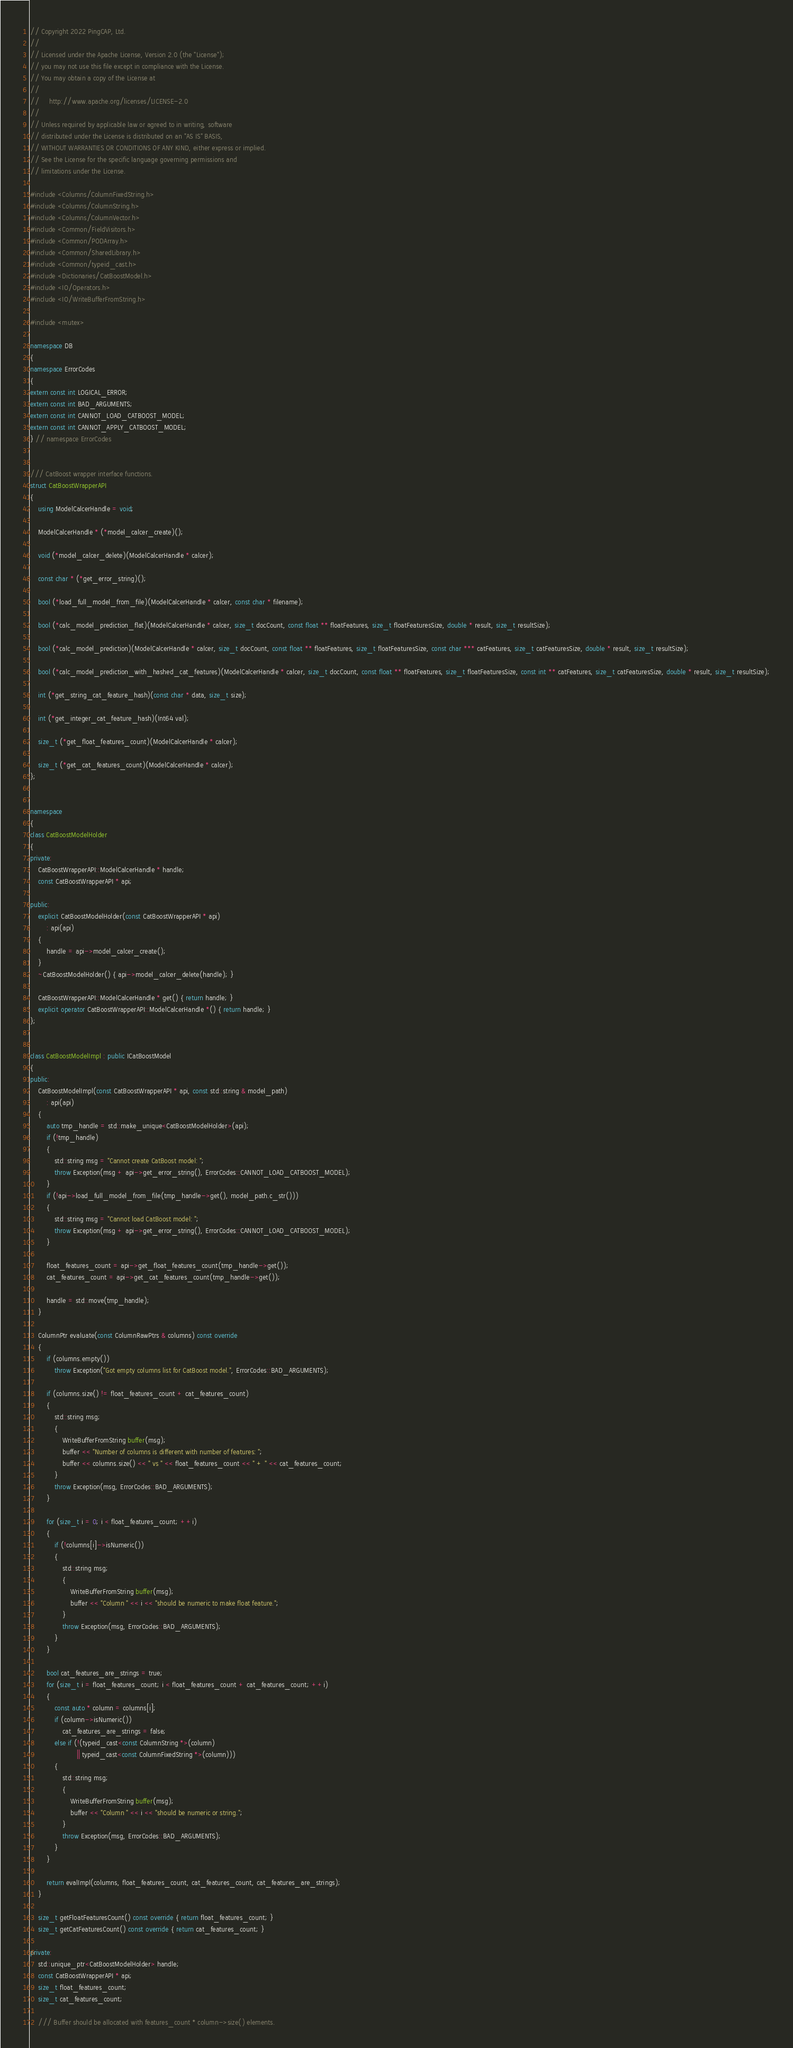<code> <loc_0><loc_0><loc_500><loc_500><_C++_>// Copyright 2022 PingCAP, Ltd.
//
// Licensed under the Apache License, Version 2.0 (the "License");
// you may not use this file except in compliance with the License.
// You may obtain a copy of the License at
//
//     http://www.apache.org/licenses/LICENSE-2.0
//
// Unless required by applicable law or agreed to in writing, software
// distributed under the License is distributed on an "AS IS" BASIS,
// WITHOUT WARRANTIES OR CONDITIONS OF ANY KIND, either express or implied.
// See the License for the specific language governing permissions and
// limitations under the License.

#include <Columns/ColumnFixedString.h>
#include <Columns/ColumnString.h>
#include <Columns/ColumnVector.h>
#include <Common/FieldVisitors.h>
#include <Common/PODArray.h>
#include <Common/SharedLibrary.h>
#include <Common/typeid_cast.h>
#include <Dictionaries/CatBoostModel.h>
#include <IO/Operators.h>
#include <IO/WriteBufferFromString.h>

#include <mutex>

namespace DB
{
namespace ErrorCodes
{
extern const int LOGICAL_ERROR;
extern const int BAD_ARGUMENTS;
extern const int CANNOT_LOAD_CATBOOST_MODEL;
extern const int CANNOT_APPLY_CATBOOST_MODEL;
} // namespace ErrorCodes


/// CatBoost wrapper interface functions.
struct CatBoostWrapperAPI
{
    using ModelCalcerHandle = void;

    ModelCalcerHandle * (*model_calcer_create)();

    void (*model_calcer_delete)(ModelCalcerHandle * calcer);

    const char * (*get_error_string)();

    bool (*load_full_model_from_file)(ModelCalcerHandle * calcer, const char * filename);

    bool (*calc_model_prediction_flat)(ModelCalcerHandle * calcer, size_t docCount, const float ** floatFeatures, size_t floatFeaturesSize, double * result, size_t resultSize);

    bool (*calc_model_prediction)(ModelCalcerHandle * calcer, size_t docCount, const float ** floatFeatures, size_t floatFeaturesSize, const char *** catFeatures, size_t catFeaturesSize, double * result, size_t resultSize);

    bool (*calc_model_prediction_with_hashed_cat_features)(ModelCalcerHandle * calcer, size_t docCount, const float ** floatFeatures, size_t floatFeaturesSize, const int ** catFeatures, size_t catFeaturesSize, double * result, size_t resultSize);

    int (*get_string_cat_feature_hash)(const char * data, size_t size);

    int (*get_integer_cat_feature_hash)(Int64 val);

    size_t (*get_float_features_count)(ModelCalcerHandle * calcer);

    size_t (*get_cat_features_count)(ModelCalcerHandle * calcer);
};


namespace
{
class CatBoostModelHolder
{
private:
    CatBoostWrapperAPI::ModelCalcerHandle * handle;
    const CatBoostWrapperAPI * api;

public:
    explicit CatBoostModelHolder(const CatBoostWrapperAPI * api)
        : api(api)
    {
        handle = api->model_calcer_create();
    }
    ~CatBoostModelHolder() { api->model_calcer_delete(handle); }

    CatBoostWrapperAPI::ModelCalcerHandle * get() { return handle; }
    explicit operator CatBoostWrapperAPI::ModelCalcerHandle *() { return handle; }
};


class CatBoostModelImpl : public ICatBoostModel
{
public:
    CatBoostModelImpl(const CatBoostWrapperAPI * api, const std::string & model_path)
        : api(api)
    {
        auto tmp_handle = std::make_unique<CatBoostModelHolder>(api);
        if (!tmp_handle)
        {
            std::string msg = "Cannot create CatBoost model: ";
            throw Exception(msg + api->get_error_string(), ErrorCodes::CANNOT_LOAD_CATBOOST_MODEL);
        }
        if (!api->load_full_model_from_file(tmp_handle->get(), model_path.c_str()))
        {
            std::string msg = "Cannot load CatBoost model: ";
            throw Exception(msg + api->get_error_string(), ErrorCodes::CANNOT_LOAD_CATBOOST_MODEL);
        }

        float_features_count = api->get_float_features_count(tmp_handle->get());
        cat_features_count = api->get_cat_features_count(tmp_handle->get());

        handle = std::move(tmp_handle);
    }

    ColumnPtr evaluate(const ColumnRawPtrs & columns) const override
    {
        if (columns.empty())
            throw Exception("Got empty columns list for CatBoost model.", ErrorCodes::BAD_ARGUMENTS);

        if (columns.size() != float_features_count + cat_features_count)
        {
            std::string msg;
            {
                WriteBufferFromString buffer(msg);
                buffer << "Number of columns is different with number of features: ";
                buffer << columns.size() << " vs " << float_features_count << " + " << cat_features_count;
            }
            throw Exception(msg, ErrorCodes::BAD_ARGUMENTS);
        }

        for (size_t i = 0; i < float_features_count; ++i)
        {
            if (!columns[i]->isNumeric())
            {
                std::string msg;
                {
                    WriteBufferFromString buffer(msg);
                    buffer << "Column " << i << "should be numeric to make float feature.";
                }
                throw Exception(msg, ErrorCodes::BAD_ARGUMENTS);
            }
        }

        bool cat_features_are_strings = true;
        for (size_t i = float_features_count; i < float_features_count + cat_features_count; ++i)
        {
            const auto * column = columns[i];
            if (column->isNumeric())
                cat_features_are_strings = false;
            else if (!(typeid_cast<const ColumnString *>(column)
                       || typeid_cast<const ColumnFixedString *>(column)))
            {
                std::string msg;
                {
                    WriteBufferFromString buffer(msg);
                    buffer << "Column " << i << "should be numeric or string.";
                }
                throw Exception(msg, ErrorCodes::BAD_ARGUMENTS);
            }
        }

        return evalImpl(columns, float_features_count, cat_features_count, cat_features_are_strings);
    }

    size_t getFloatFeaturesCount() const override { return float_features_count; }
    size_t getCatFeaturesCount() const override { return cat_features_count; }

private:
    std::unique_ptr<CatBoostModelHolder> handle;
    const CatBoostWrapperAPI * api;
    size_t float_features_count;
    size_t cat_features_count;

    /// Buffer should be allocated with features_count * column->size() elements.</code> 